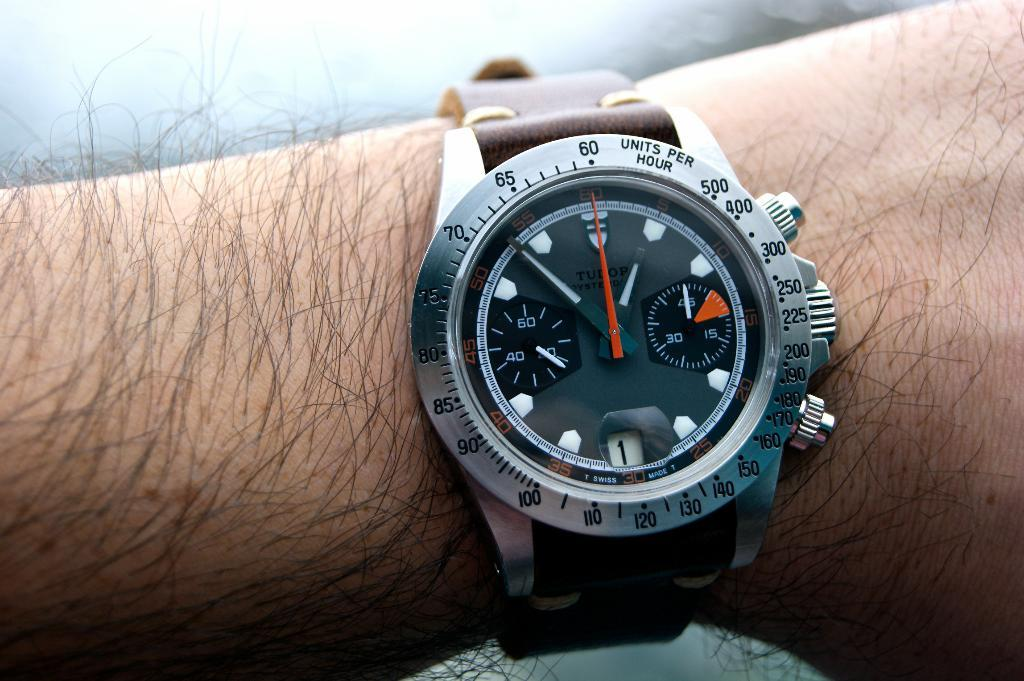<image>
Write a terse but informative summary of the picture. A wrist with a Tudor Watch with Units Per Hour on the outer ring. 